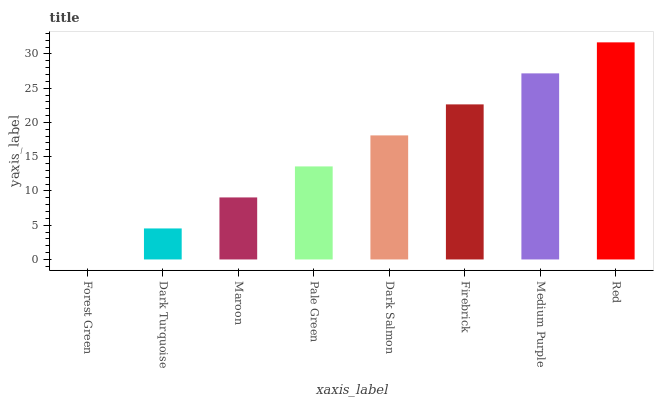Is Dark Turquoise the minimum?
Answer yes or no. No. Is Dark Turquoise the maximum?
Answer yes or no. No. Is Dark Turquoise greater than Forest Green?
Answer yes or no. Yes. Is Forest Green less than Dark Turquoise?
Answer yes or no. Yes. Is Forest Green greater than Dark Turquoise?
Answer yes or no. No. Is Dark Turquoise less than Forest Green?
Answer yes or no. No. Is Dark Salmon the high median?
Answer yes or no. Yes. Is Pale Green the low median?
Answer yes or no. Yes. Is Firebrick the high median?
Answer yes or no. No. Is Red the low median?
Answer yes or no. No. 